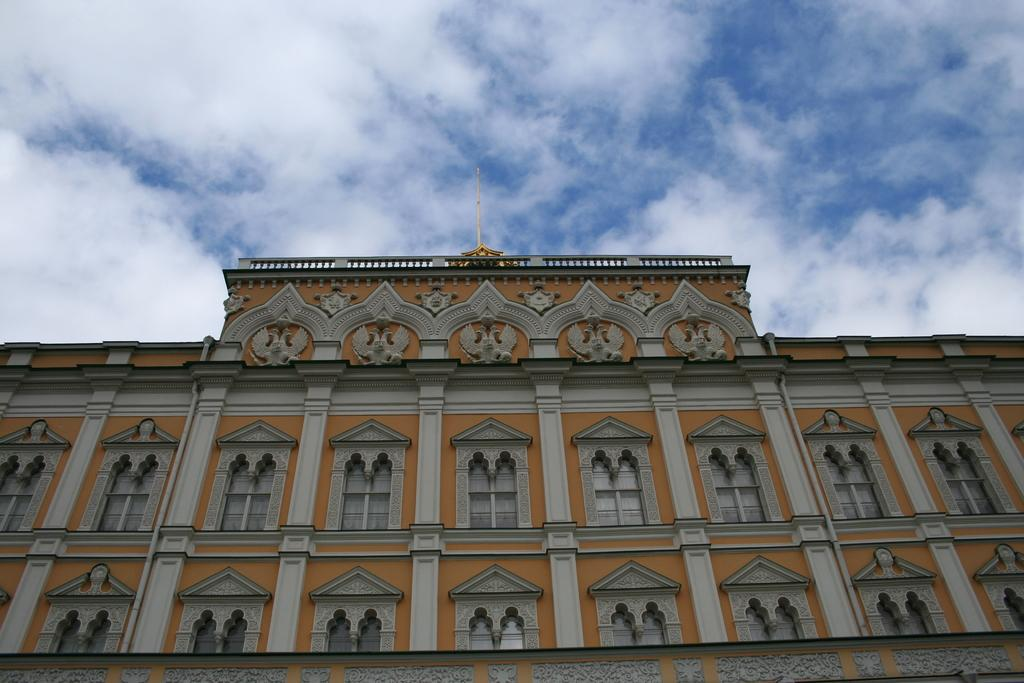What is the main subject of the image? The main subject of the image is a building. What specific features can be observed on the building? The building has windows and pillars. What is visible at the top of the image? The sky is visible at the top of the image. Can you hear the boy coughing in the image? There is no boy or any sound mentioned in the image, so it is not possible to determine if someone is coughing. 